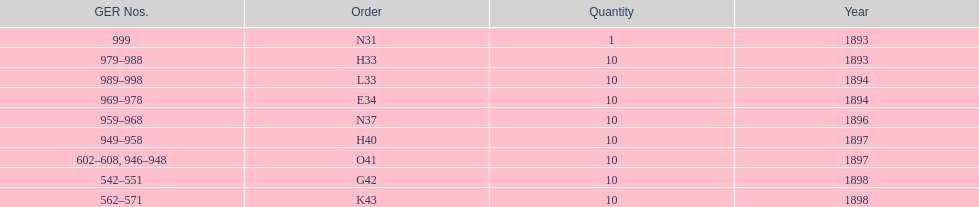What order is listed first at the top of the table? N31. 